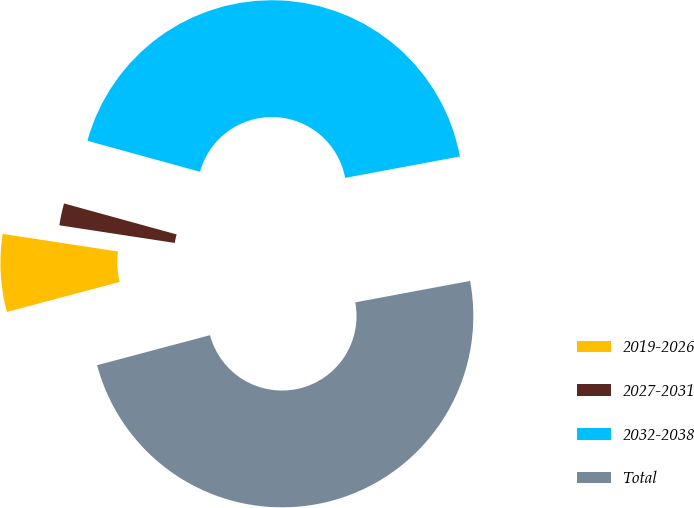<chart> <loc_0><loc_0><loc_500><loc_500><pie_chart><fcel>2019-2026<fcel>2027-2031<fcel>2032-2038<fcel>Total<nl><fcel>6.55%<fcel>1.86%<fcel>42.79%<fcel>48.8%<nl></chart> 